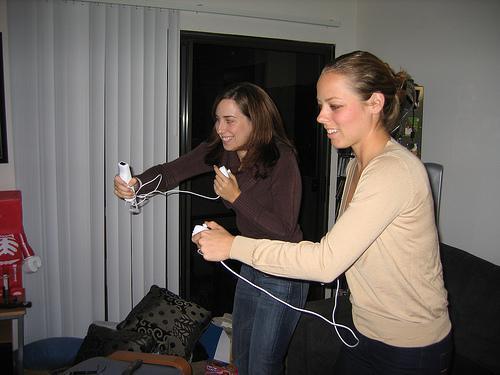How many ponytail holders are in the girl's hair?
Give a very brief answer. 1. How many couches can you see?
Give a very brief answer. 2. How many people are there?
Give a very brief answer. 2. 